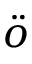Convert formula to latex. <formula><loc_0><loc_0><loc_500><loc_500>\ddot { o }</formula> 